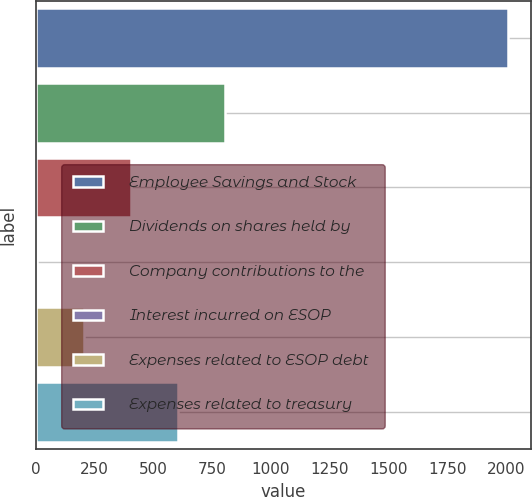Convert chart to OTSL. <chart><loc_0><loc_0><loc_500><loc_500><bar_chart><fcel>Employee Savings and Stock<fcel>Dividends on shares held by<fcel>Company contributions to the<fcel>Interest incurred on ESOP<fcel>Expenses related to ESOP debt<fcel>Expenses related to treasury<nl><fcel>2007<fcel>805.8<fcel>405.4<fcel>5<fcel>205.2<fcel>605.6<nl></chart> 